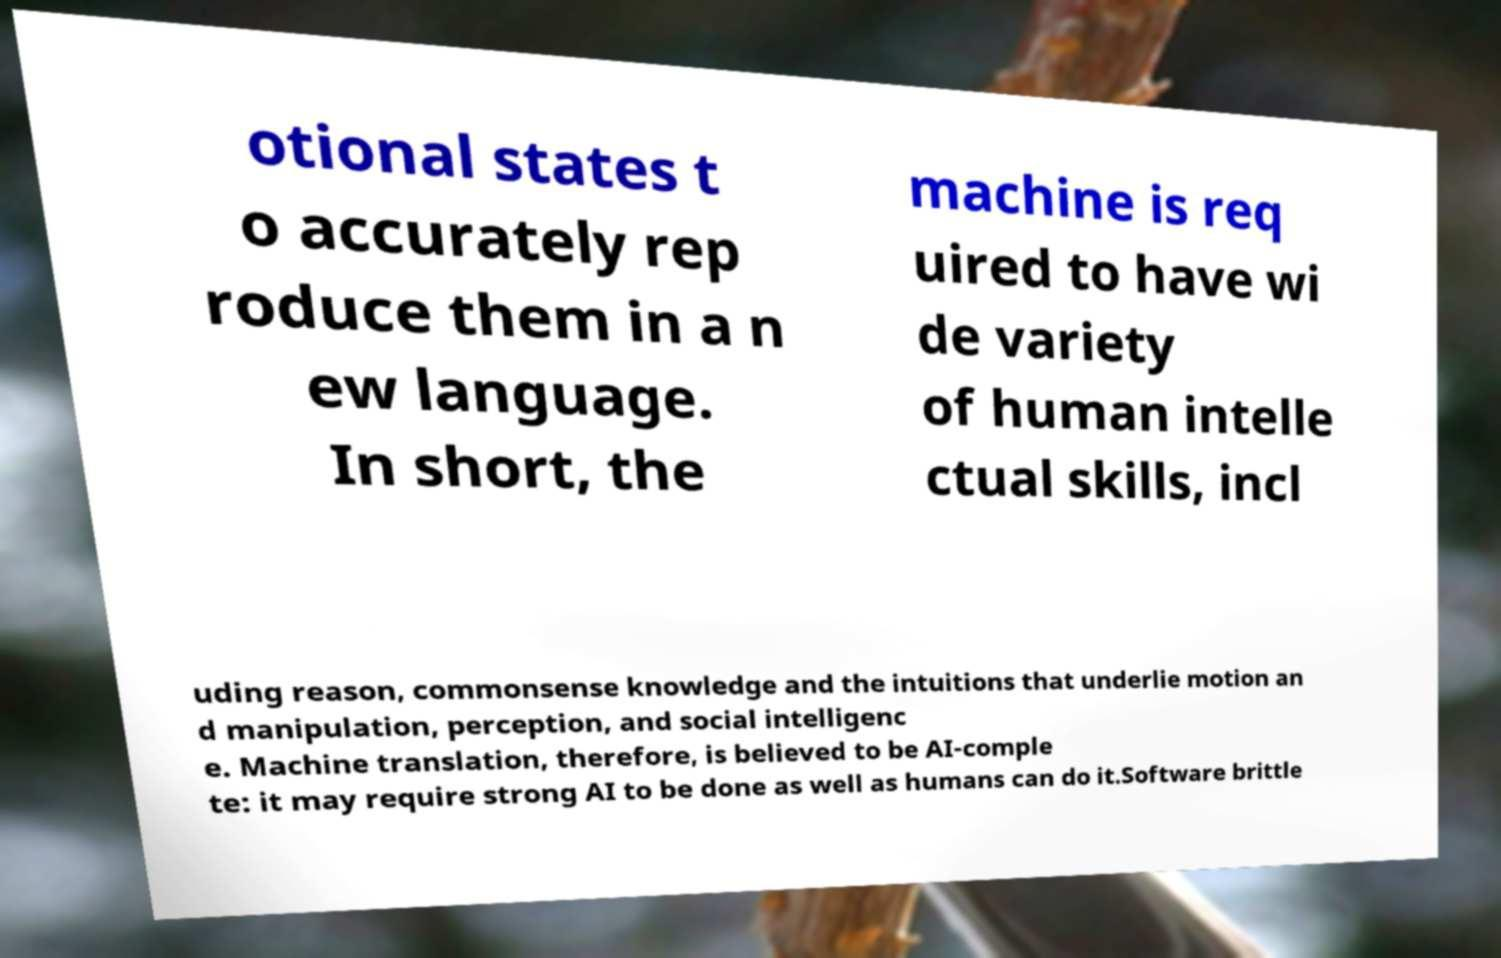Please read and relay the text visible in this image. What does it say? otional states t o accurately rep roduce them in a n ew language. In short, the machine is req uired to have wi de variety of human intelle ctual skills, incl uding reason, commonsense knowledge and the intuitions that underlie motion an d manipulation, perception, and social intelligenc e. Machine translation, therefore, is believed to be AI-comple te: it may require strong AI to be done as well as humans can do it.Software brittle 